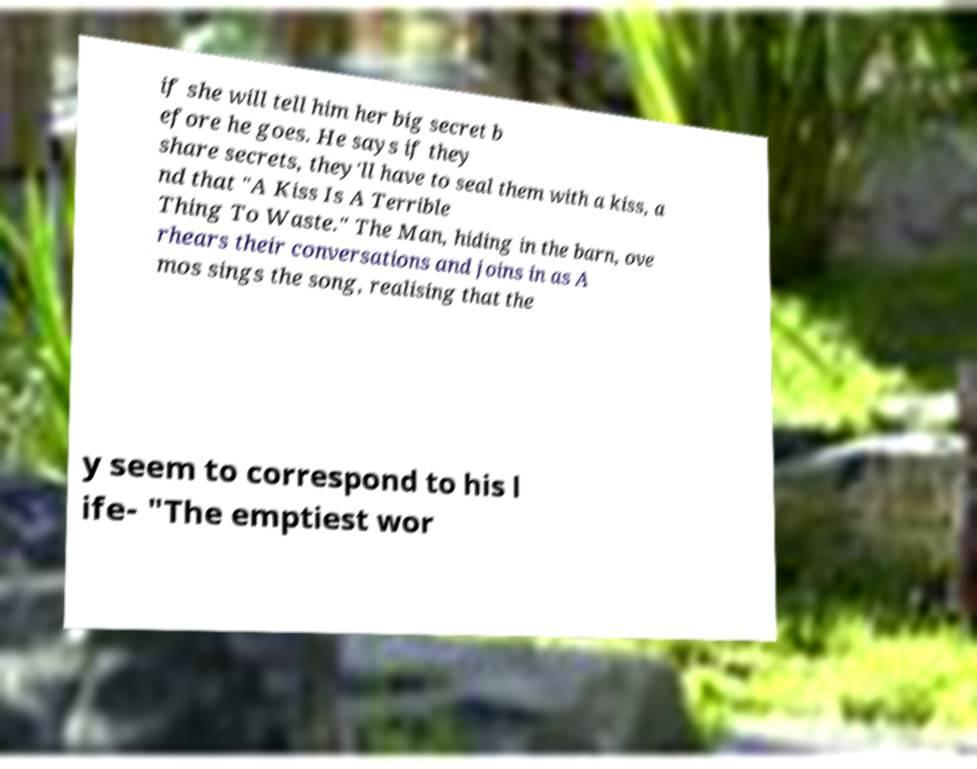I need the written content from this picture converted into text. Can you do that? if she will tell him her big secret b efore he goes. He says if they share secrets, they'll have to seal them with a kiss, a nd that "A Kiss Is A Terrible Thing To Waste." The Man, hiding in the barn, ove rhears their conversations and joins in as A mos sings the song, realising that the y seem to correspond to his l ife- "The emptiest wor 